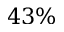<formula> <loc_0><loc_0><loc_500><loc_500>4 3 \%</formula> 